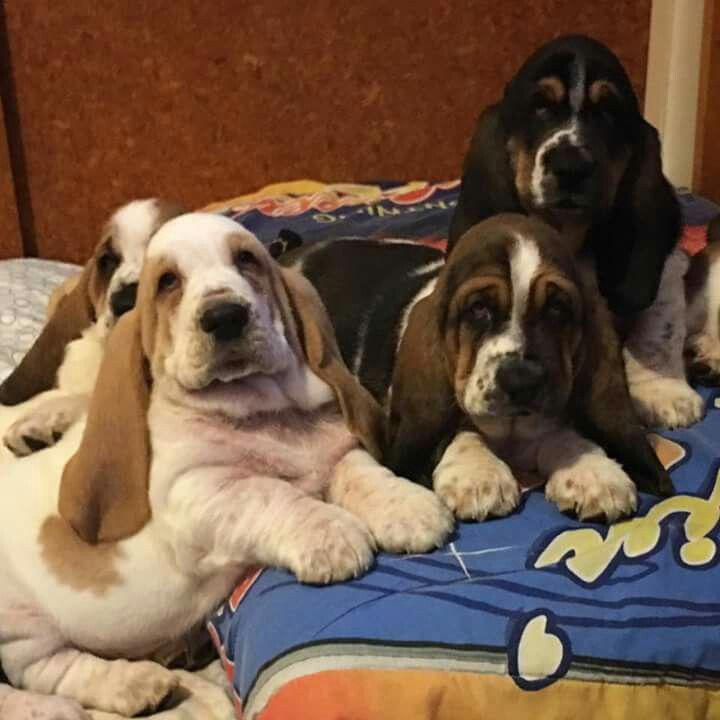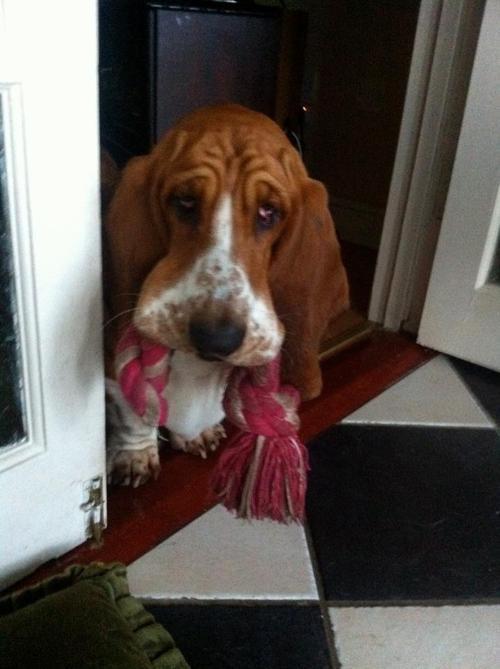The first image is the image on the left, the second image is the image on the right. Given the left and right images, does the statement "Each image shows exactly one dog, which is a long-eared hound." hold true? Answer yes or no. No. The first image is the image on the left, the second image is the image on the right. Evaluate the accuracy of this statement regarding the images: "There are a total of 4 dogs". Is it true? Answer yes or no. No. 